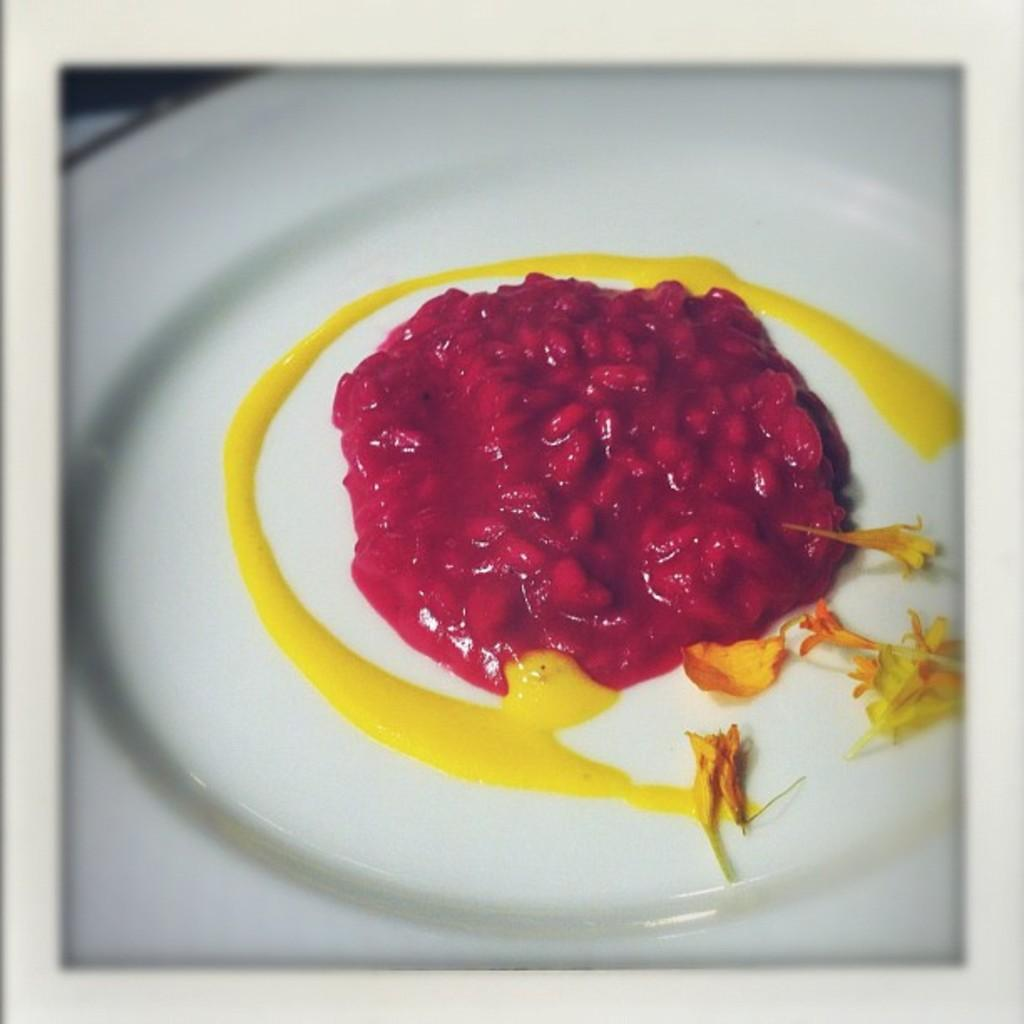What is present in the image? There is food in the image. What is the color of the plate on which the food is placed? The plate is white in color. What colors can be seen in the food? The food has red and yellow colors. What type of spade is being used to dig in the food? There is no spade present in the image, and the food is not being dug into. 